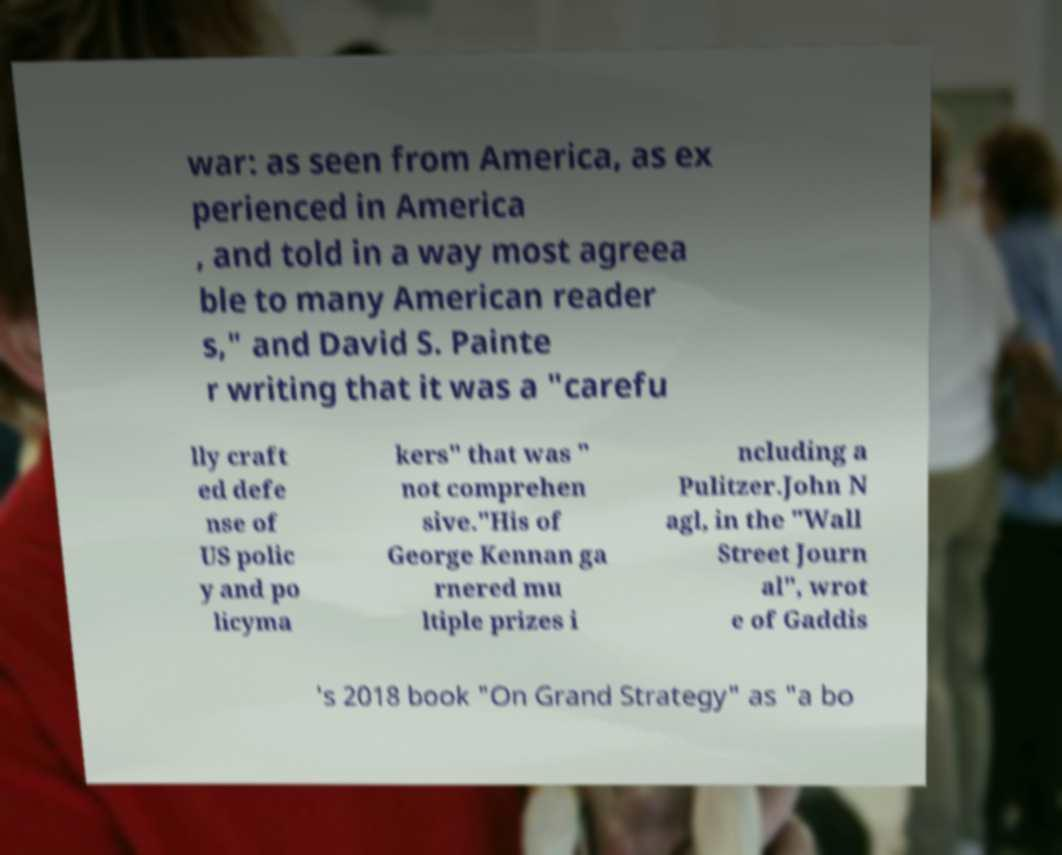There's text embedded in this image that I need extracted. Can you transcribe it verbatim? war: as seen from America, as ex perienced in America , and told in a way most agreea ble to many American reader s," and David S. Painte r writing that it was a "carefu lly craft ed defe nse of US polic y and po licyma kers" that was " not comprehen sive."His of George Kennan ga rnered mu ltiple prizes i ncluding a Pulitzer.John N agl, in the "Wall Street Journ al", wrot e of Gaddis 's 2018 book "On Grand Strategy" as "a bo 